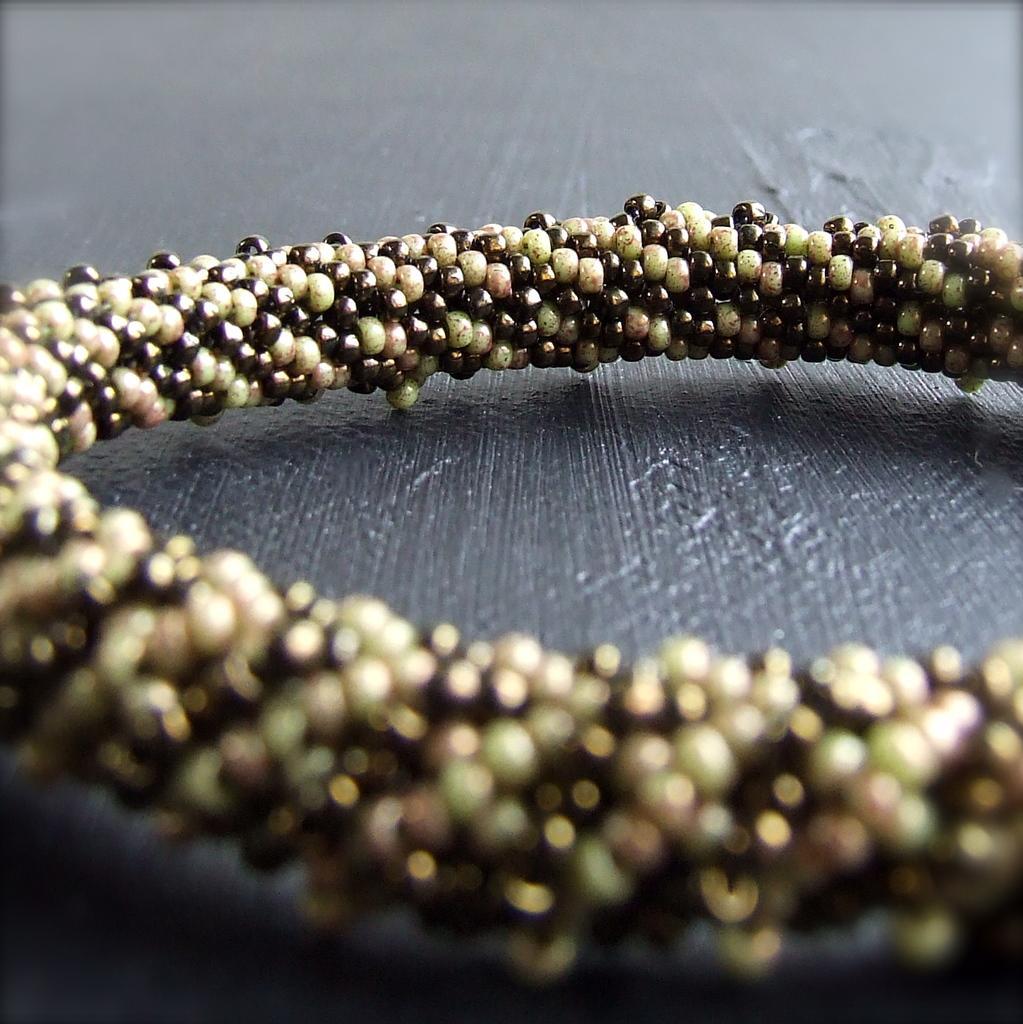Describe this image in one or two sentences. This image consists of a bangle, kept on a table. The table is in black color. 